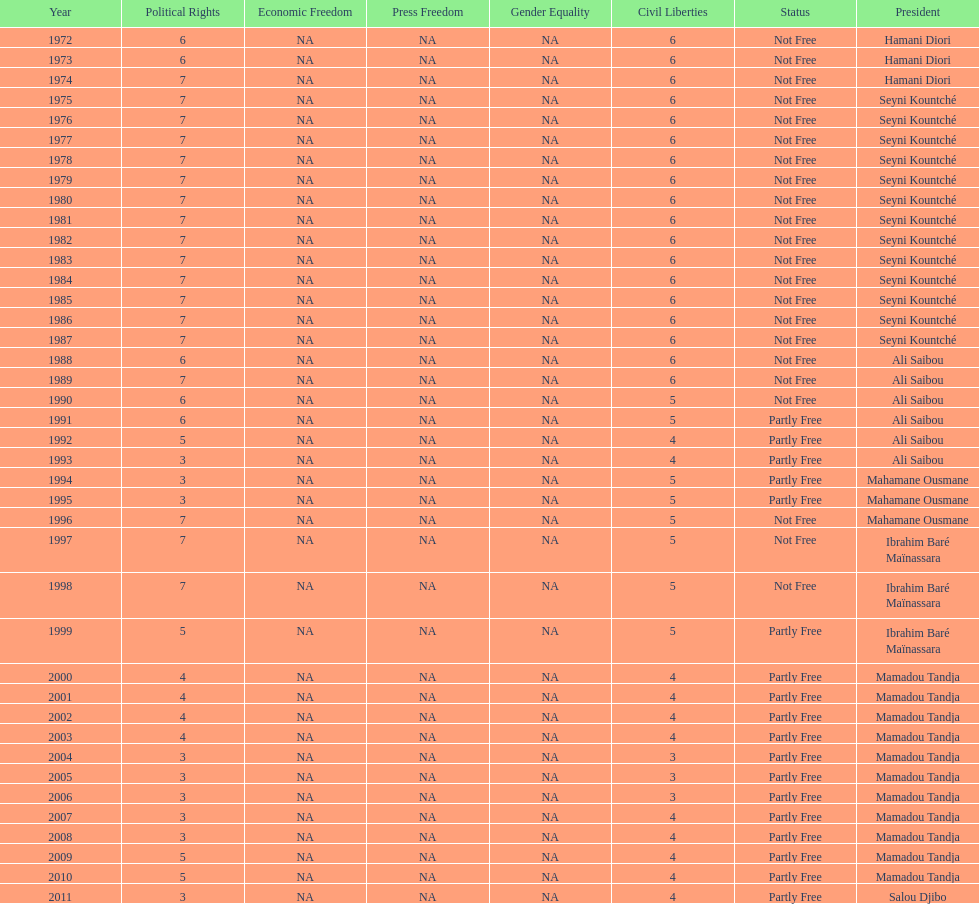How long did it take for civil liberties to decrease below 6? 18 years. 